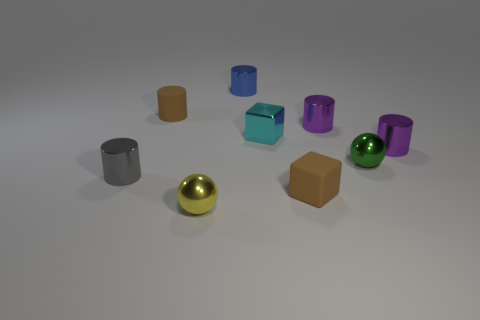Do the small rubber cylinder and the matte object that is right of the yellow metal sphere have the same color?
Your response must be concise. Yes. What is the color of the matte cylinder?
Make the answer very short. Brown. There is a object behind the brown object behind the purple metal cylinder that is in front of the tiny shiny cube; what is its shape?
Offer a terse response. Cylinder. What number of other things are the same color as the metal block?
Your response must be concise. 0. Is the number of small things that are in front of the small brown rubber cylinder greater than the number of small green objects behind the green metallic object?
Provide a short and direct response. Yes. Are there any tiny gray objects left of the small gray metal thing?
Offer a terse response. No. There is a cylinder that is both in front of the cyan thing and right of the yellow ball; what is its material?
Keep it short and to the point. Metal. There is another rubber object that is the same shape as the small cyan thing; what color is it?
Give a very brief answer. Brown. There is a brown matte thing that is behind the green metallic sphere; is there a cylinder to the right of it?
Offer a very short reply. Yes. What is the size of the cyan block?
Provide a succinct answer. Small. 